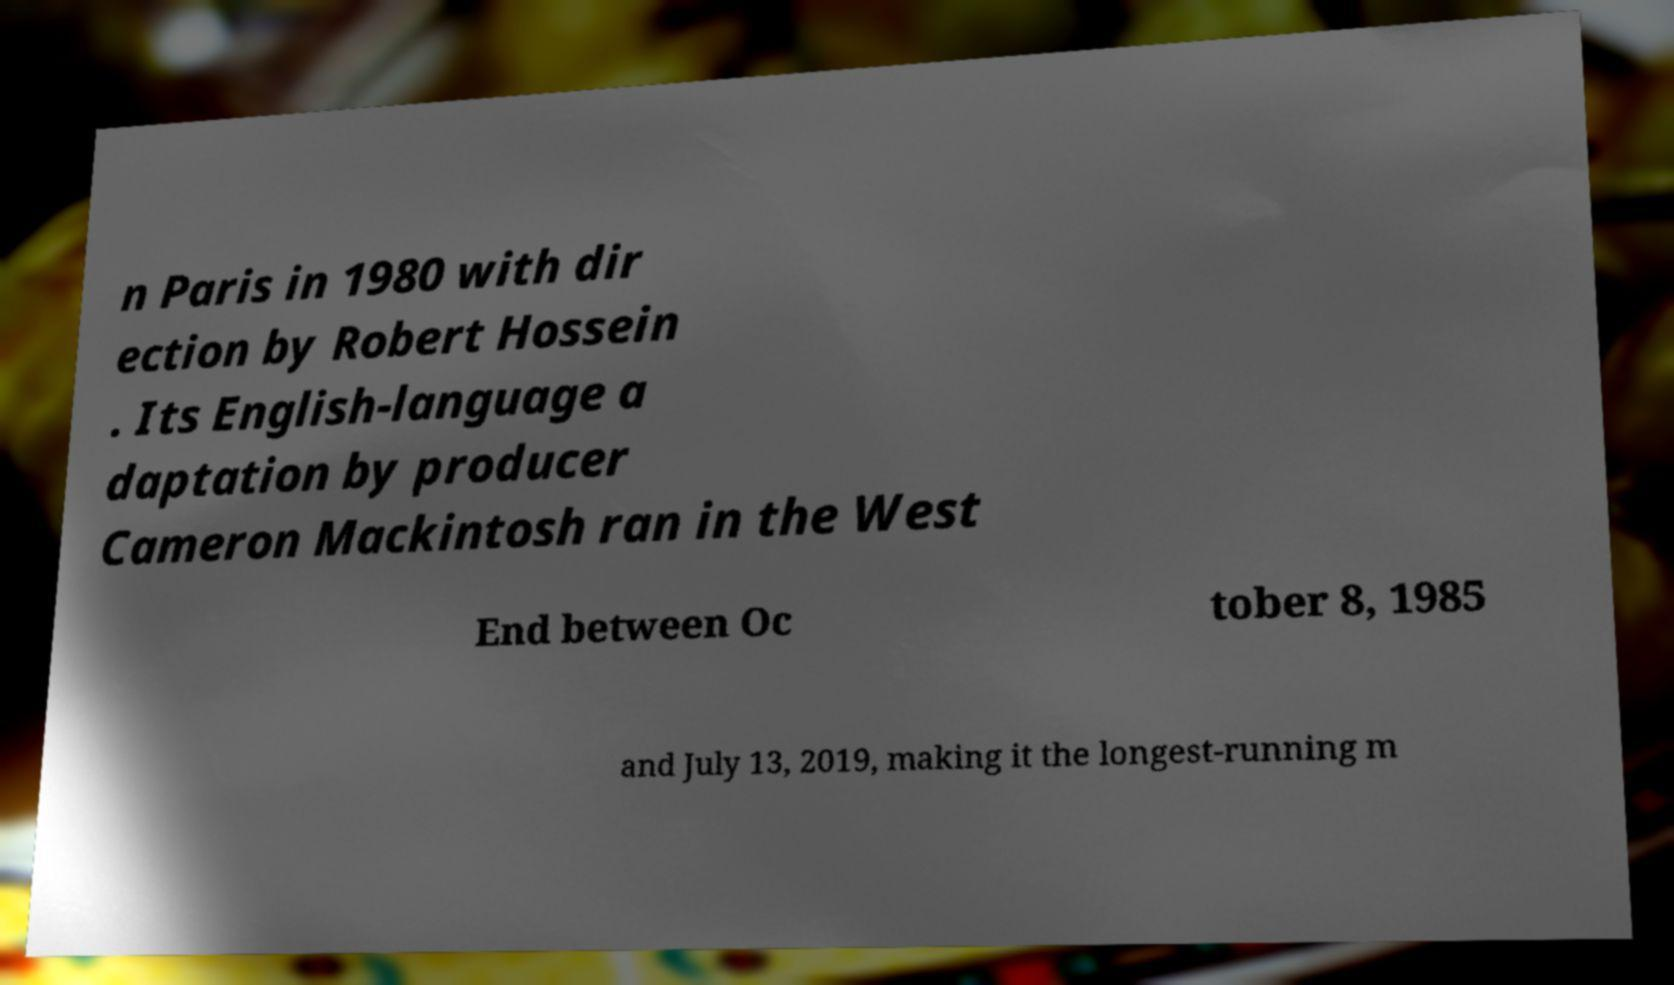Can you accurately transcribe the text from the provided image for me? n Paris in 1980 with dir ection by Robert Hossein . Its English-language a daptation by producer Cameron Mackintosh ran in the West End between Oc tober 8, 1985 and July 13, 2019, making it the longest-running m 